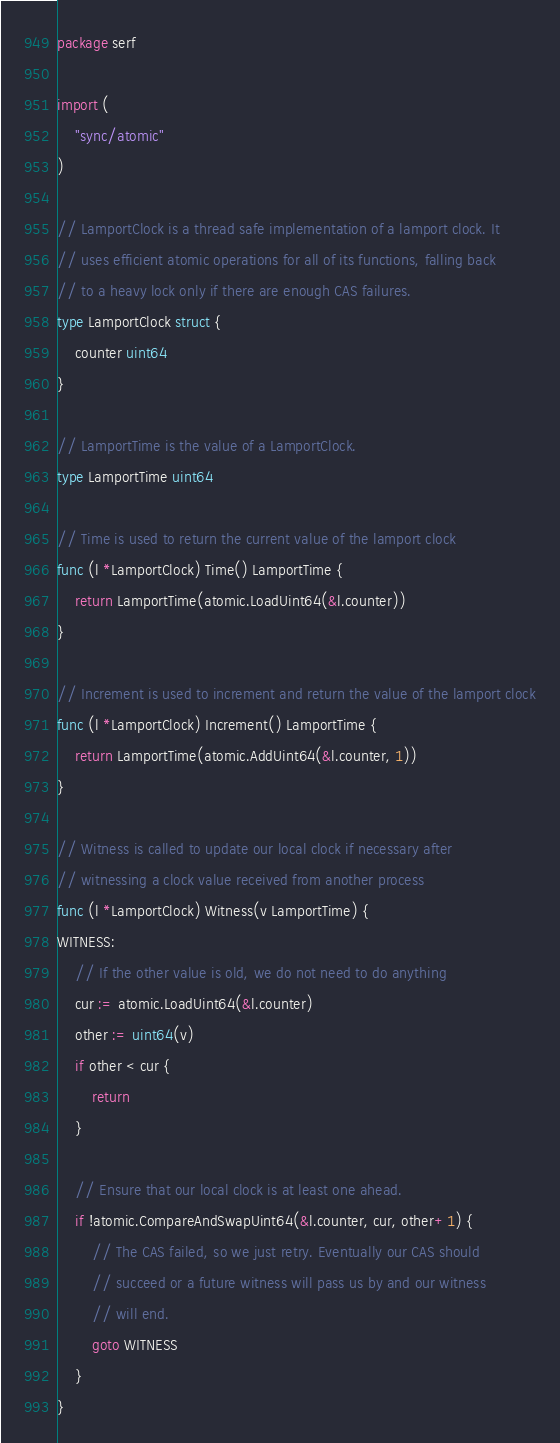<code> <loc_0><loc_0><loc_500><loc_500><_Go_>package serf

import (
	"sync/atomic"
)

// LamportClock is a thread safe implementation of a lamport clock. It
// uses efficient atomic operations for all of its functions, falling back
// to a heavy lock only if there are enough CAS failures.
type LamportClock struct {
	counter uint64
}

// LamportTime is the value of a LamportClock.
type LamportTime uint64

// Time is used to return the current value of the lamport clock
func (l *LamportClock) Time() LamportTime {
	return LamportTime(atomic.LoadUint64(&l.counter))
}

// Increment is used to increment and return the value of the lamport clock
func (l *LamportClock) Increment() LamportTime {
	return LamportTime(atomic.AddUint64(&l.counter, 1))
}

// Witness is called to update our local clock if necessary after
// witnessing a clock value received from another process
func (l *LamportClock) Witness(v LamportTime) {
WITNESS:
	// If the other value is old, we do not need to do anything
	cur := atomic.LoadUint64(&l.counter)
	other := uint64(v)
	if other < cur {
		return
	}

	// Ensure that our local clock is at least one ahead.
	if !atomic.CompareAndSwapUint64(&l.counter, cur, other+1) {
		// The CAS failed, so we just retry. Eventually our CAS should
		// succeed or a future witness will pass us by and our witness
		// will end.
		goto WITNESS
	}
}
</code> 